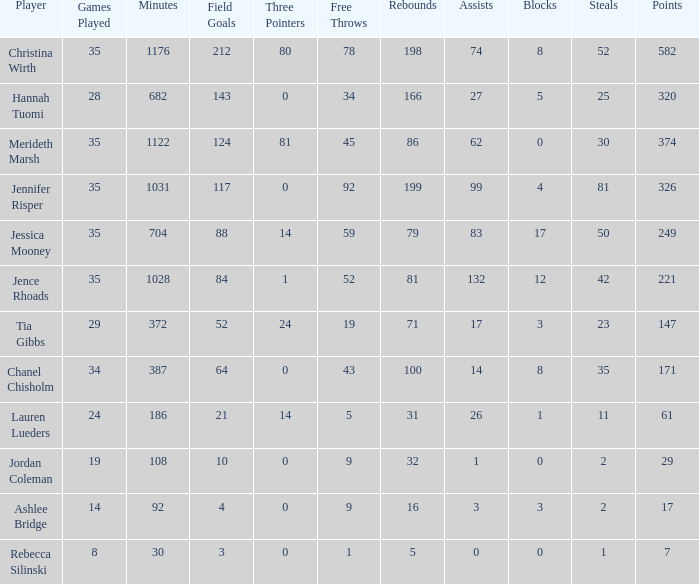How much time, in minutes, did Chanel Chisholm play? 1.0. 